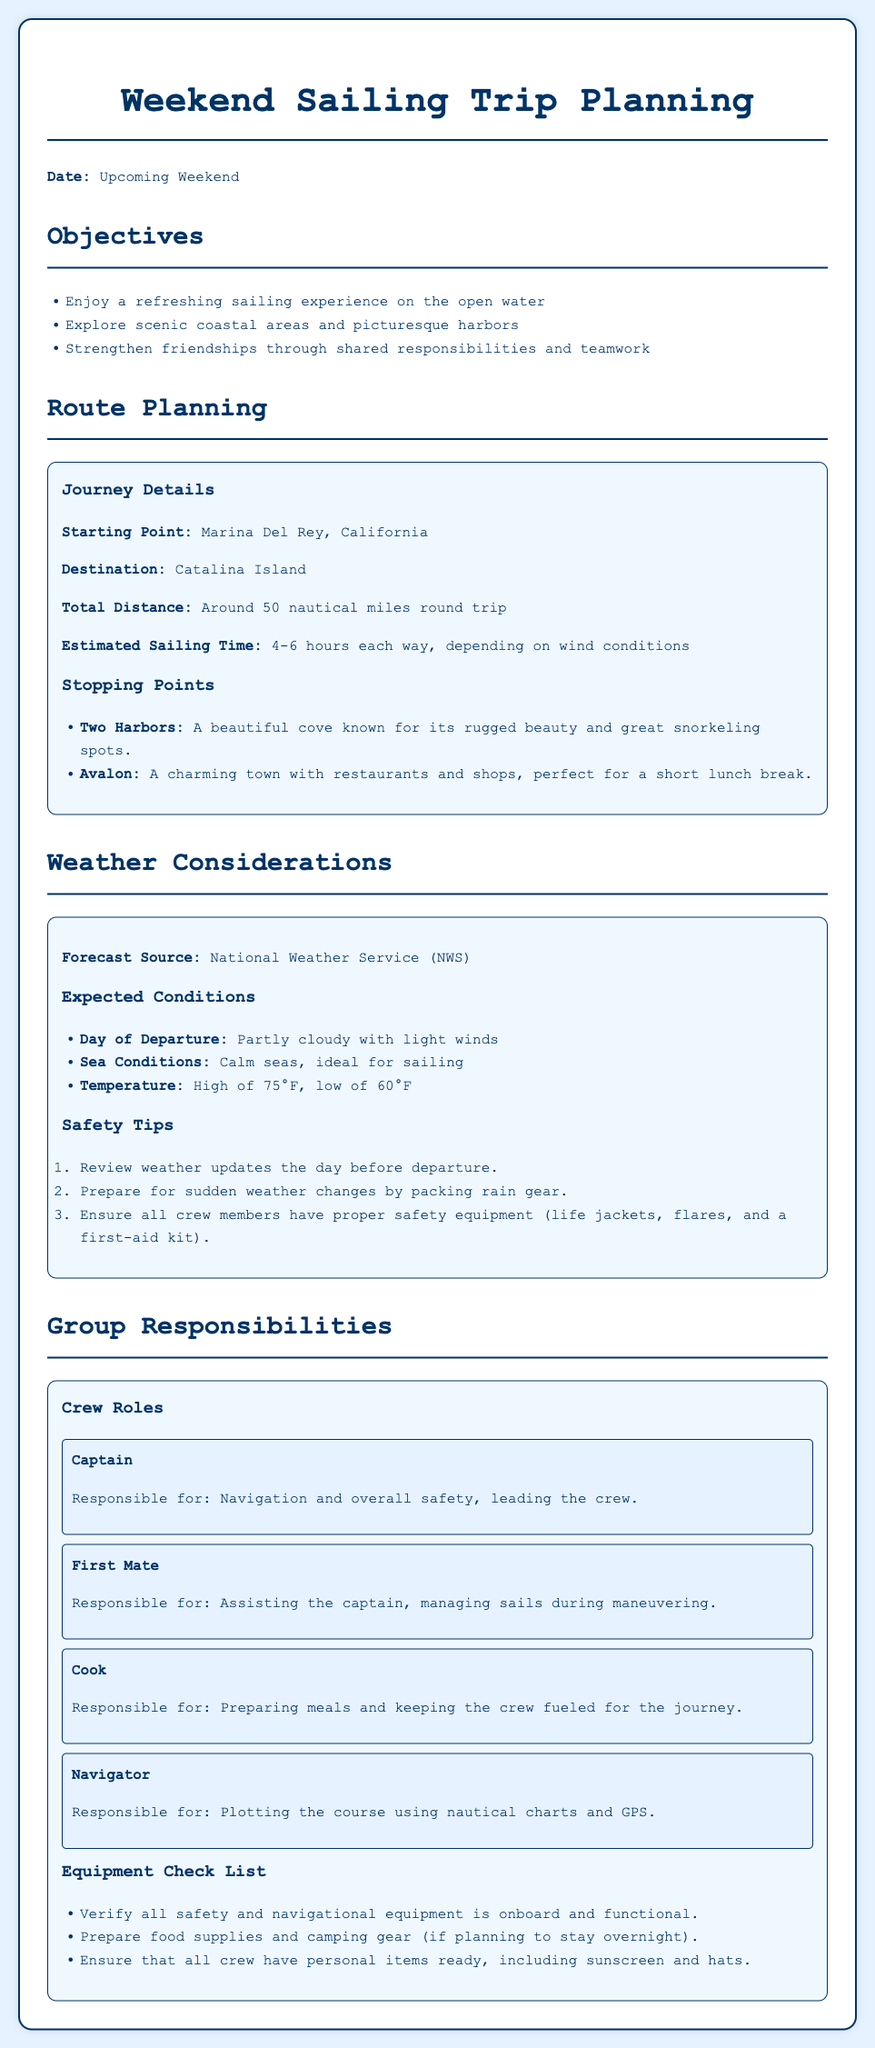What is the starting point of the sailing trip? The starting point is stated in the route planning section of the document.
Answer: Marina Del Rey, California What is the destination for the trip? The destination is mentioned in the route planning section.
Answer: Catalina Island How many nautical miles is the total distance of the trip? The total distance is specified in the journey details of the route planning section.
Answer: Around 50 nautical miles What is the expected weather condition on the day of departure? The weather condition is outlined in the expected conditions section.
Answer: Partly cloudy with light winds Who is responsible for navigation and overall safety? Crew roles describe the responsibilities of each crew member.
Answer: Captain What is one of the stopping points during the trip? The stopping points list in the route planning section provides this information.
Answer: Two Harbors How long is the estimated sailing time each way? The estimated sailing time is mentioned in the journey details.
Answer: 4-6 hours Which organization is the source for the weather forecast? The document states the source in the weather considerations section.
Answer: National Weather Service (NWS) What should be prepared for sudden weather changes? The safety tips list indicates what should be on hand for weather changes.
Answer: Rain gear 